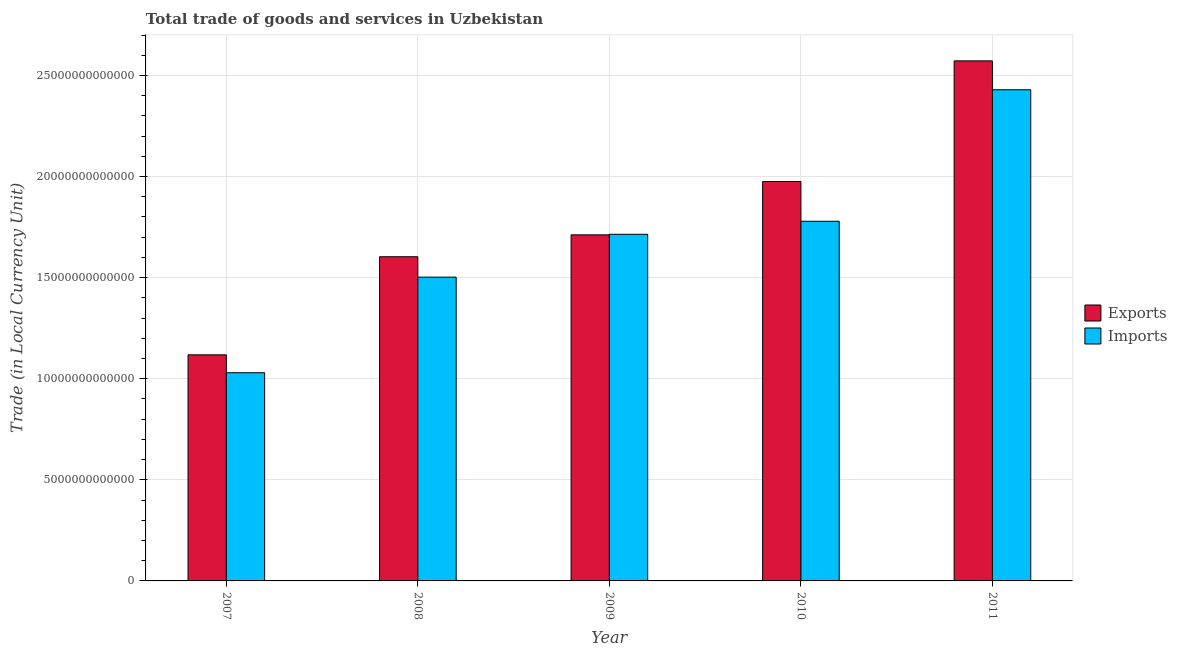How many different coloured bars are there?
Ensure brevity in your answer.  2. How many groups of bars are there?
Your answer should be very brief. 5. Are the number of bars per tick equal to the number of legend labels?
Give a very brief answer. Yes. Are the number of bars on each tick of the X-axis equal?
Offer a terse response. Yes. How many bars are there on the 5th tick from the right?
Offer a terse response. 2. What is the label of the 4th group of bars from the left?
Your answer should be compact. 2010. In how many cases, is the number of bars for a given year not equal to the number of legend labels?
Your answer should be very brief. 0. What is the export of goods and services in 2009?
Your answer should be very brief. 1.71e+13. Across all years, what is the maximum export of goods and services?
Offer a terse response. 2.57e+13. Across all years, what is the minimum export of goods and services?
Your response must be concise. 1.12e+13. In which year was the imports of goods and services maximum?
Provide a short and direct response. 2011. What is the total export of goods and services in the graph?
Your answer should be compact. 8.98e+13. What is the difference between the export of goods and services in 2010 and that in 2011?
Ensure brevity in your answer.  -5.97e+12. What is the difference between the export of goods and services in 2009 and the imports of goods and services in 2008?
Ensure brevity in your answer.  1.08e+12. What is the average imports of goods and services per year?
Offer a very short reply. 1.69e+13. What is the ratio of the imports of goods and services in 2009 to that in 2010?
Keep it short and to the point. 0.96. Is the export of goods and services in 2009 less than that in 2011?
Your answer should be very brief. Yes. What is the difference between the highest and the second highest imports of goods and services?
Keep it short and to the point. 6.50e+12. What is the difference between the highest and the lowest export of goods and services?
Provide a succinct answer. 1.45e+13. What does the 2nd bar from the left in 2009 represents?
Your answer should be very brief. Imports. What does the 1st bar from the right in 2007 represents?
Offer a very short reply. Imports. How many bars are there?
Offer a very short reply. 10. How many years are there in the graph?
Make the answer very short. 5. What is the difference between two consecutive major ticks on the Y-axis?
Provide a succinct answer. 5.00e+12. Does the graph contain any zero values?
Your answer should be compact. No. Does the graph contain grids?
Your answer should be compact. Yes. How are the legend labels stacked?
Your answer should be compact. Vertical. What is the title of the graph?
Offer a very short reply. Total trade of goods and services in Uzbekistan. What is the label or title of the Y-axis?
Ensure brevity in your answer.  Trade (in Local Currency Unit). What is the Trade (in Local Currency Unit) in Exports in 2007?
Offer a very short reply. 1.12e+13. What is the Trade (in Local Currency Unit) of Imports in 2007?
Your answer should be compact. 1.03e+13. What is the Trade (in Local Currency Unit) in Exports in 2008?
Offer a very short reply. 1.60e+13. What is the Trade (in Local Currency Unit) in Imports in 2008?
Provide a succinct answer. 1.50e+13. What is the Trade (in Local Currency Unit) of Exports in 2009?
Your answer should be compact. 1.71e+13. What is the Trade (in Local Currency Unit) in Imports in 2009?
Offer a very short reply. 1.71e+13. What is the Trade (in Local Currency Unit) of Exports in 2010?
Ensure brevity in your answer.  1.98e+13. What is the Trade (in Local Currency Unit) of Imports in 2010?
Make the answer very short. 1.78e+13. What is the Trade (in Local Currency Unit) in Exports in 2011?
Your response must be concise. 2.57e+13. What is the Trade (in Local Currency Unit) of Imports in 2011?
Your answer should be compact. 2.43e+13. Across all years, what is the maximum Trade (in Local Currency Unit) in Exports?
Your answer should be very brief. 2.57e+13. Across all years, what is the maximum Trade (in Local Currency Unit) of Imports?
Keep it short and to the point. 2.43e+13. Across all years, what is the minimum Trade (in Local Currency Unit) in Exports?
Make the answer very short. 1.12e+13. Across all years, what is the minimum Trade (in Local Currency Unit) in Imports?
Make the answer very short. 1.03e+13. What is the total Trade (in Local Currency Unit) of Exports in the graph?
Your answer should be very brief. 8.98e+13. What is the total Trade (in Local Currency Unit) of Imports in the graph?
Ensure brevity in your answer.  8.45e+13. What is the difference between the Trade (in Local Currency Unit) of Exports in 2007 and that in 2008?
Give a very brief answer. -4.85e+12. What is the difference between the Trade (in Local Currency Unit) in Imports in 2007 and that in 2008?
Offer a very short reply. -4.73e+12. What is the difference between the Trade (in Local Currency Unit) of Exports in 2007 and that in 2009?
Your response must be concise. -5.93e+12. What is the difference between the Trade (in Local Currency Unit) in Imports in 2007 and that in 2009?
Provide a short and direct response. -6.85e+12. What is the difference between the Trade (in Local Currency Unit) of Exports in 2007 and that in 2010?
Make the answer very short. -8.57e+12. What is the difference between the Trade (in Local Currency Unit) of Imports in 2007 and that in 2010?
Provide a short and direct response. -7.49e+12. What is the difference between the Trade (in Local Currency Unit) in Exports in 2007 and that in 2011?
Your response must be concise. -1.45e+13. What is the difference between the Trade (in Local Currency Unit) in Imports in 2007 and that in 2011?
Your answer should be compact. -1.40e+13. What is the difference between the Trade (in Local Currency Unit) in Exports in 2008 and that in 2009?
Provide a succinct answer. -1.08e+12. What is the difference between the Trade (in Local Currency Unit) of Imports in 2008 and that in 2009?
Ensure brevity in your answer.  -2.12e+12. What is the difference between the Trade (in Local Currency Unit) in Exports in 2008 and that in 2010?
Keep it short and to the point. -3.72e+12. What is the difference between the Trade (in Local Currency Unit) of Imports in 2008 and that in 2010?
Offer a terse response. -2.76e+12. What is the difference between the Trade (in Local Currency Unit) of Exports in 2008 and that in 2011?
Provide a succinct answer. -9.69e+12. What is the difference between the Trade (in Local Currency Unit) of Imports in 2008 and that in 2011?
Offer a terse response. -9.27e+12. What is the difference between the Trade (in Local Currency Unit) of Exports in 2009 and that in 2010?
Keep it short and to the point. -2.64e+12. What is the difference between the Trade (in Local Currency Unit) in Imports in 2009 and that in 2010?
Provide a short and direct response. -6.45e+11. What is the difference between the Trade (in Local Currency Unit) in Exports in 2009 and that in 2011?
Provide a succinct answer. -8.60e+12. What is the difference between the Trade (in Local Currency Unit) in Imports in 2009 and that in 2011?
Make the answer very short. -7.15e+12. What is the difference between the Trade (in Local Currency Unit) in Exports in 2010 and that in 2011?
Offer a very short reply. -5.97e+12. What is the difference between the Trade (in Local Currency Unit) in Imports in 2010 and that in 2011?
Provide a succinct answer. -6.50e+12. What is the difference between the Trade (in Local Currency Unit) of Exports in 2007 and the Trade (in Local Currency Unit) of Imports in 2008?
Provide a short and direct response. -3.84e+12. What is the difference between the Trade (in Local Currency Unit) of Exports in 2007 and the Trade (in Local Currency Unit) of Imports in 2009?
Make the answer very short. -5.96e+12. What is the difference between the Trade (in Local Currency Unit) in Exports in 2007 and the Trade (in Local Currency Unit) in Imports in 2010?
Your answer should be very brief. -6.61e+12. What is the difference between the Trade (in Local Currency Unit) of Exports in 2007 and the Trade (in Local Currency Unit) of Imports in 2011?
Your answer should be compact. -1.31e+13. What is the difference between the Trade (in Local Currency Unit) in Exports in 2008 and the Trade (in Local Currency Unit) in Imports in 2009?
Offer a terse response. -1.11e+12. What is the difference between the Trade (in Local Currency Unit) in Exports in 2008 and the Trade (in Local Currency Unit) in Imports in 2010?
Give a very brief answer. -1.76e+12. What is the difference between the Trade (in Local Currency Unit) of Exports in 2008 and the Trade (in Local Currency Unit) of Imports in 2011?
Make the answer very short. -8.26e+12. What is the difference between the Trade (in Local Currency Unit) of Exports in 2009 and the Trade (in Local Currency Unit) of Imports in 2010?
Make the answer very short. -6.72e+11. What is the difference between the Trade (in Local Currency Unit) in Exports in 2009 and the Trade (in Local Currency Unit) in Imports in 2011?
Offer a terse response. -7.18e+12. What is the difference between the Trade (in Local Currency Unit) in Exports in 2010 and the Trade (in Local Currency Unit) in Imports in 2011?
Offer a terse response. -4.54e+12. What is the average Trade (in Local Currency Unit) in Exports per year?
Give a very brief answer. 1.80e+13. What is the average Trade (in Local Currency Unit) of Imports per year?
Make the answer very short. 1.69e+13. In the year 2007, what is the difference between the Trade (in Local Currency Unit) of Exports and Trade (in Local Currency Unit) of Imports?
Your answer should be compact. 8.86e+11. In the year 2008, what is the difference between the Trade (in Local Currency Unit) of Exports and Trade (in Local Currency Unit) of Imports?
Your answer should be very brief. 1.01e+12. In the year 2009, what is the difference between the Trade (in Local Currency Unit) of Exports and Trade (in Local Currency Unit) of Imports?
Keep it short and to the point. -2.72e+1. In the year 2010, what is the difference between the Trade (in Local Currency Unit) in Exports and Trade (in Local Currency Unit) in Imports?
Give a very brief answer. 1.96e+12. In the year 2011, what is the difference between the Trade (in Local Currency Unit) of Exports and Trade (in Local Currency Unit) of Imports?
Your answer should be very brief. 1.43e+12. What is the ratio of the Trade (in Local Currency Unit) in Exports in 2007 to that in 2008?
Ensure brevity in your answer.  0.7. What is the ratio of the Trade (in Local Currency Unit) in Imports in 2007 to that in 2008?
Provide a short and direct response. 0.69. What is the ratio of the Trade (in Local Currency Unit) of Exports in 2007 to that in 2009?
Your answer should be compact. 0.65. What is the ratio of the Trade (in Local Currency Unit) in Imports in 2007 to that in 2009?
Your answer should be very brief. 0.6. What is the ratio of the Trade (in Local Currency Unit) of Exports in 2007 to that in 2010?
Make the answer very short. 0.57. What is the ratio of the Trade (in Local Currency Unit) in Imports in 2007 to that in 2010?
Provide a short and direct response. 0.58. What is the ratio of the Trade (in Local Currency Unit) in Exports in 2007 to that in 2011?
Your answer should be compact. 0.43. What is the ratio of the Trade (in Local Currency Unit) of Imports in 2007 to that in 2011?
Your response must be concise. 0.42. What is the ratio of the Trade (in Local Currency Unit) of Exports in 2008 to that in 2009?
Your answer should be compact. 0.94. What is the ratio of the Trade (in Local Currency Unit) in Imports in 2008 to that in 2009?
Provide a short and direct response. 0.88. What is the ratio of the Trade (in Local Currency Unit) in Exports in 2008 to that in 2010?
Ensure brevity in your answer.  0.81. What is the ratio of the Trade (in Local Currency Unit) in Imports in 2008 to that in 2010?
Offer a very short reply. 0.84. What is the ratio of the Trade (in Local Currency Unit) in Exports in 2008 to that in 2011?
Give a very brief answer. 0.62. What is the ratio of the Trade (in Local Currency Unit) in Imports in 2008 to that in 2011?
Give a very brief answer. 0.62. What is the ratio of the Trade (in Local Currency Unit) of Exports in 2009 to that in 2010?
Ensure brevity in your answer.  0.87. What is the ratio of the Trade (in Local Currency Unit) in Imports in 2009 to that in 2010?
Provide a succinct answer. 0.96. What is the ratio of the Trade (in Local Currency Unit) in Exports in 2009 to that in 2011?
Offer a terse response. 0.67. What is the ratio of the Trade (in Local Currency Unit) in Imports in 2009 to that in 2011?
Offer a terse response. 0.71. What is the ratio of the Trade (in Local Currency Unit) of Exports in 2010 to that in 2011?
Your response must be concise. 0.77. What is the ratio of the Trade (in Local Currency Unit) of Imports in 2010 to that in 2011?
Your answer should be compact. 0.73. What is the difference between the highest and the second highest Trade (in Local Currency Unit) in Exports?
Your answer should be very brief. 5.97e+12. What is the difference between the highest and the second highest Trade (in Local Currency Unit) in Imports?
Make the answer very short. 6.50e+12. What is the difference between the highest and the lowest Trade (in Local Currency Unit) of Exports?
Your response must be concise. 1.45e+13. What is the difference between the highest and the lowest Trade (in Local Currency Unit) in Imports?
Your answer should be compact. 1.40e+13. 